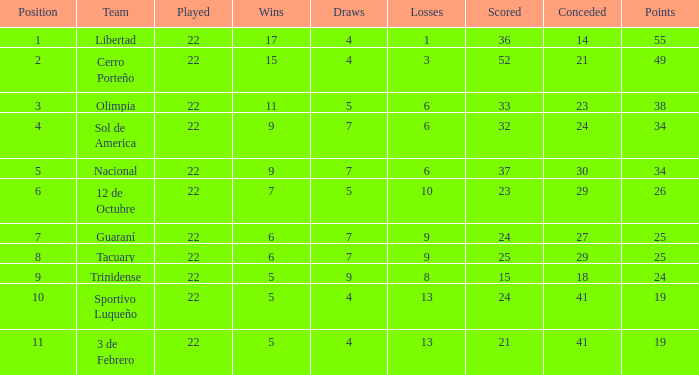What was the number of losses when the scored value was 25? 9.0. Would you be able to parse every entry in this table? {'header': ['Position', 'Team', 'Played', 'Wins', 'Draws', 'Losses', 'Scored', 'Conceded', 'Points'], 'rows': [['1', 'Libertad', '22', '17', '4', '1', '36', '14', '55'], ['2', 'Cerro Porteño', '22', '15', '4', '3', '52', '21', '49'], ['3', 'Olimpia', '22', '11', '5', '6', '33', '23', '38'], ['4', 'Sol de America', '22', '9', '7', '6', '32', '24', '34'], ['5', 'Nacional', '22', '9', '7', '6', '37', '30', '34'], ['6', '12 de Octubre', '22', '7', '5', '10', '23', '29', '26'], ['7', 'Guaraní', '22', '6', '7', '9', '24', '27', '25'], ['8', 'Tacuary', '22', '6', '7', '9', '25', '29', '25'], ['9', 'Trinidense', '22', '5', '9', '8', '15', '18', '24'], ['10', 'Sportivo Luqueño', '22', '5', '4', '13', '24', '41', '19'], ['11', '3 de Febrero', '22', '5', '4', '13', '21', '41', '19']]} 